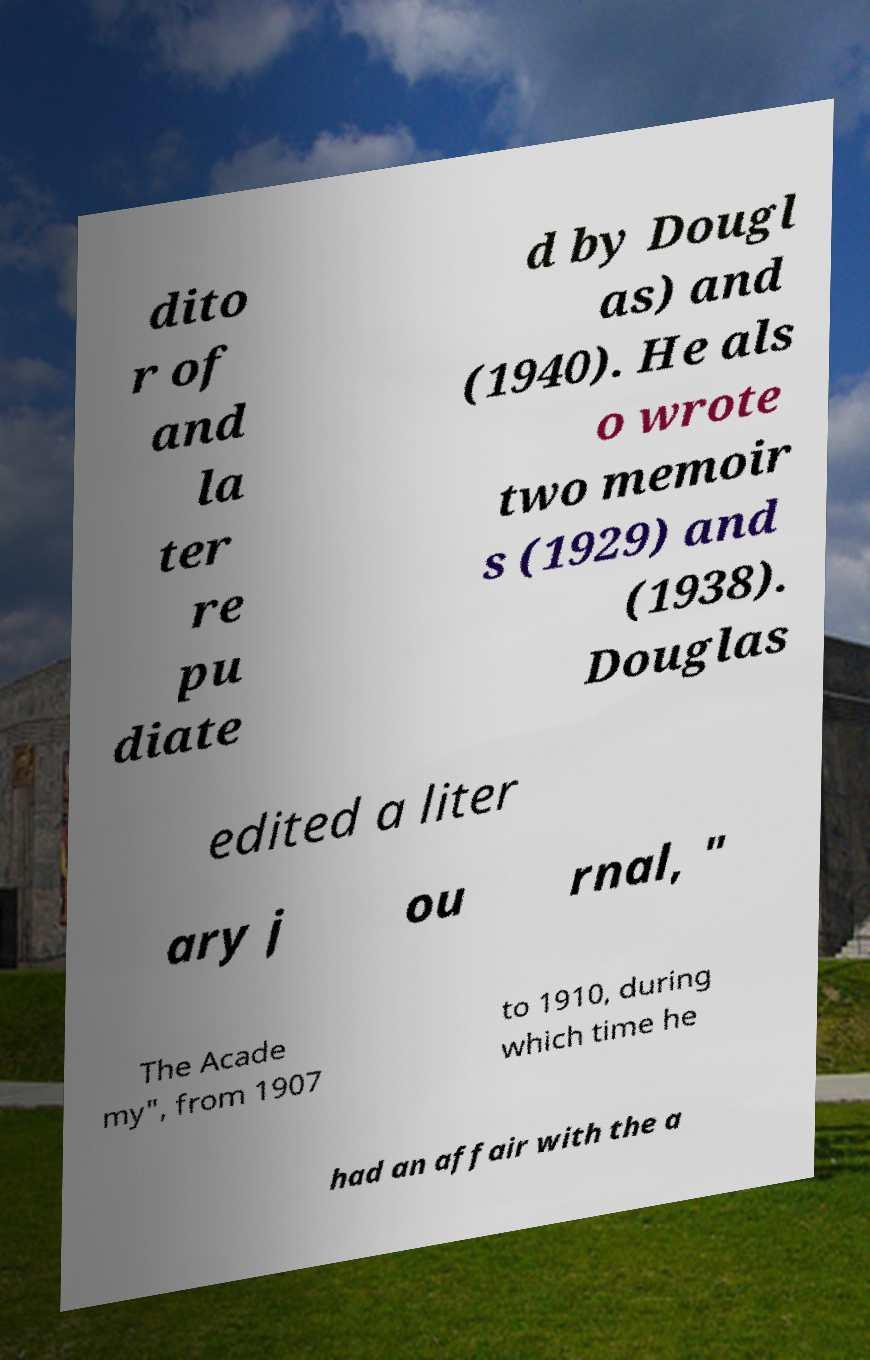Could you assist in decoding the text presented in this image and type it out clearly? dito r of and la ter re pu diate d by Dougl as) and (1940). He als o wrote two memoir s (1929) and (1938). Douglas edited a liter ary j ou rnal, " The Acade my", from 1907 to 1910, during which time he had an affair with the a 